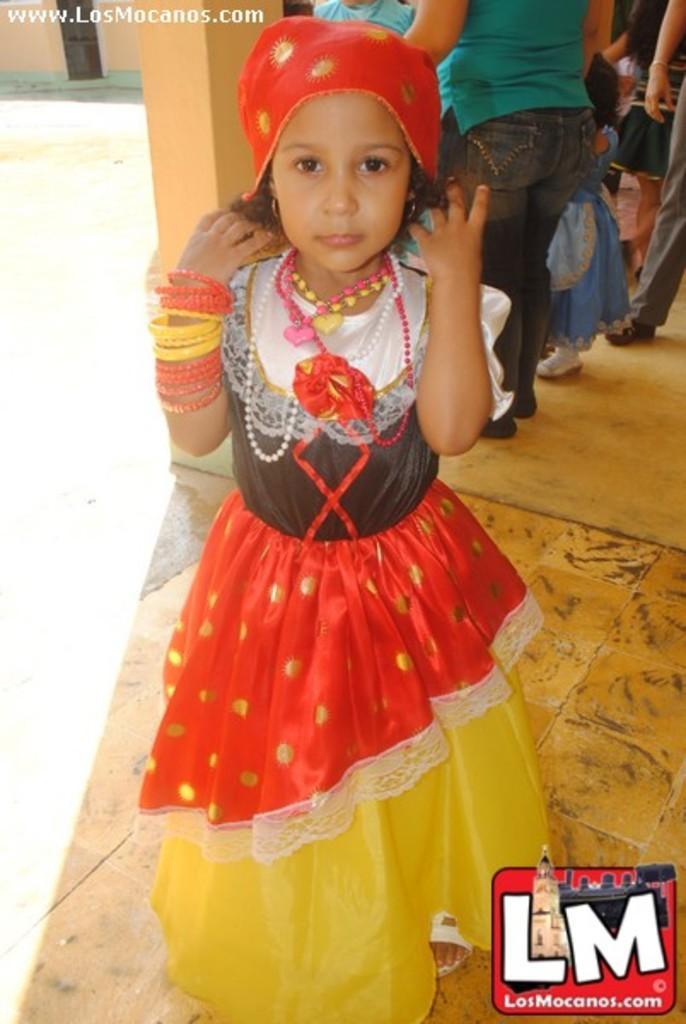Can you describe this image briefly? This image consists of a girl wearing a red color headgear is standing. At the bottom, there is a floor. In the background, there are many people. And we can see a pillar. 